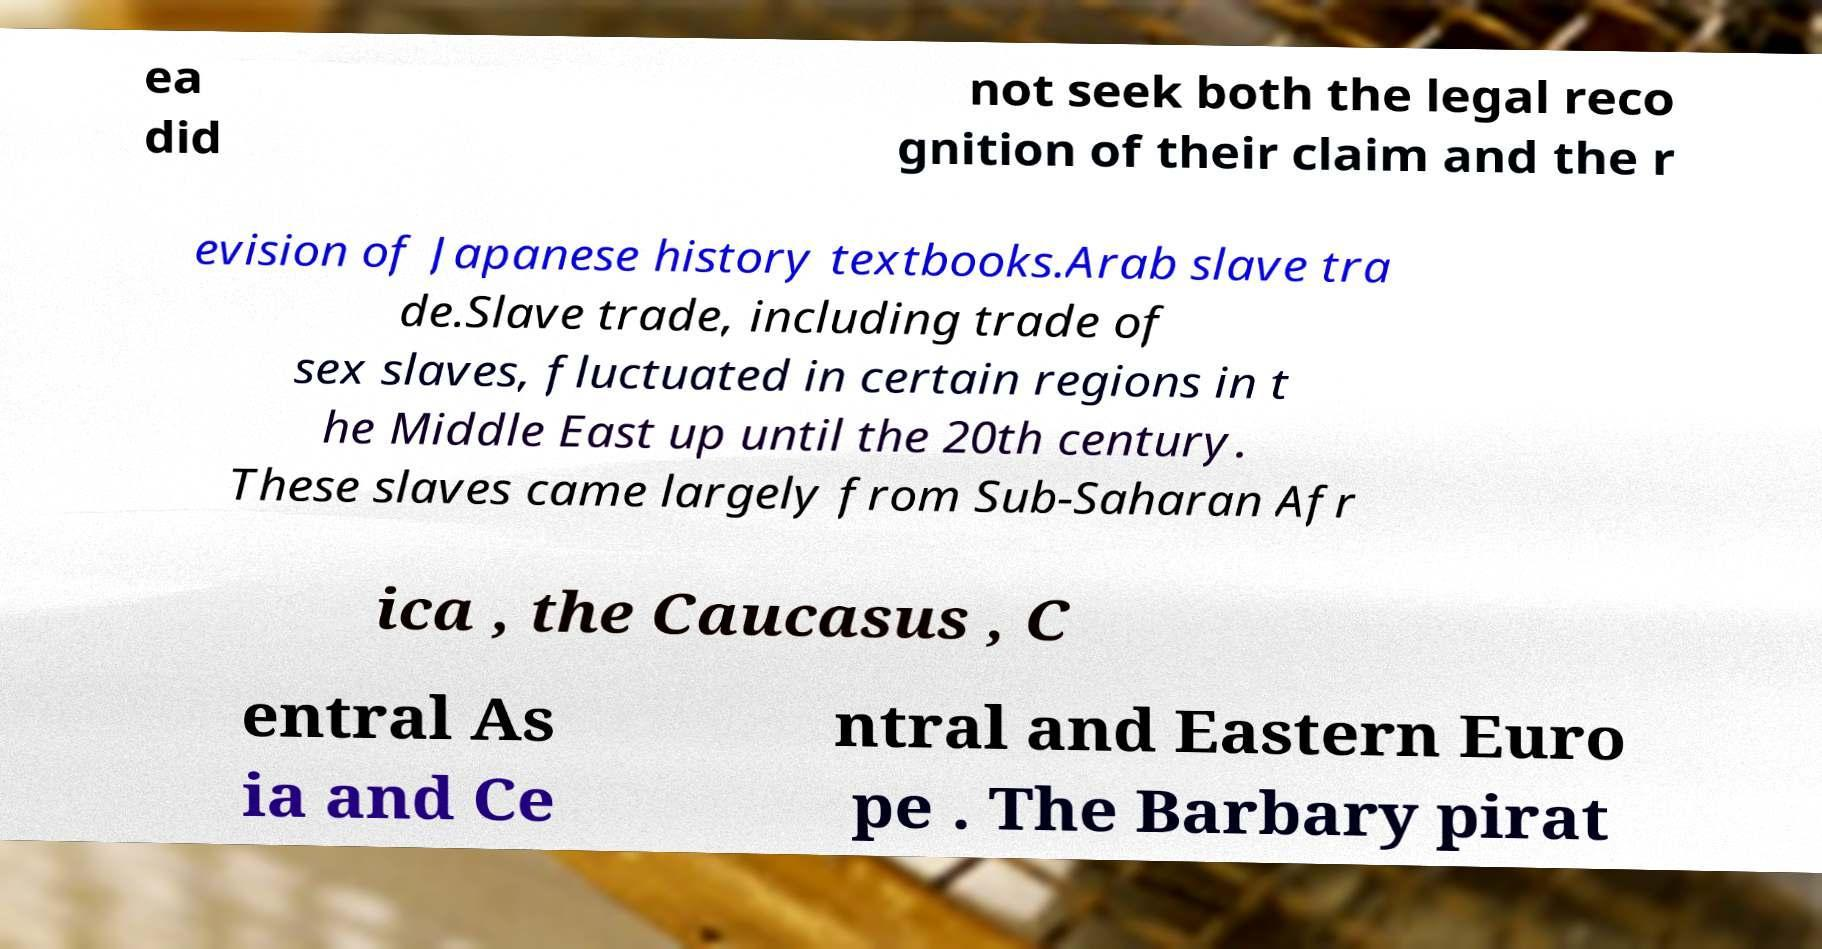I need the written content from this picture converted into text. Can you do that? ea did not seek both the legal reco gnition of their claim and the r evision of Japanese history textbooks.Arab slave tra de.Slave trade, including trade of sex slaves, fluctuated in certain regions in t he Middle East up until the 20th century. These slaves came largely from Sub-Saharan Afr ica , the Caucasus , C entral As ia and Ce ntral and Eastern Euro pe . The Barbary pirat 